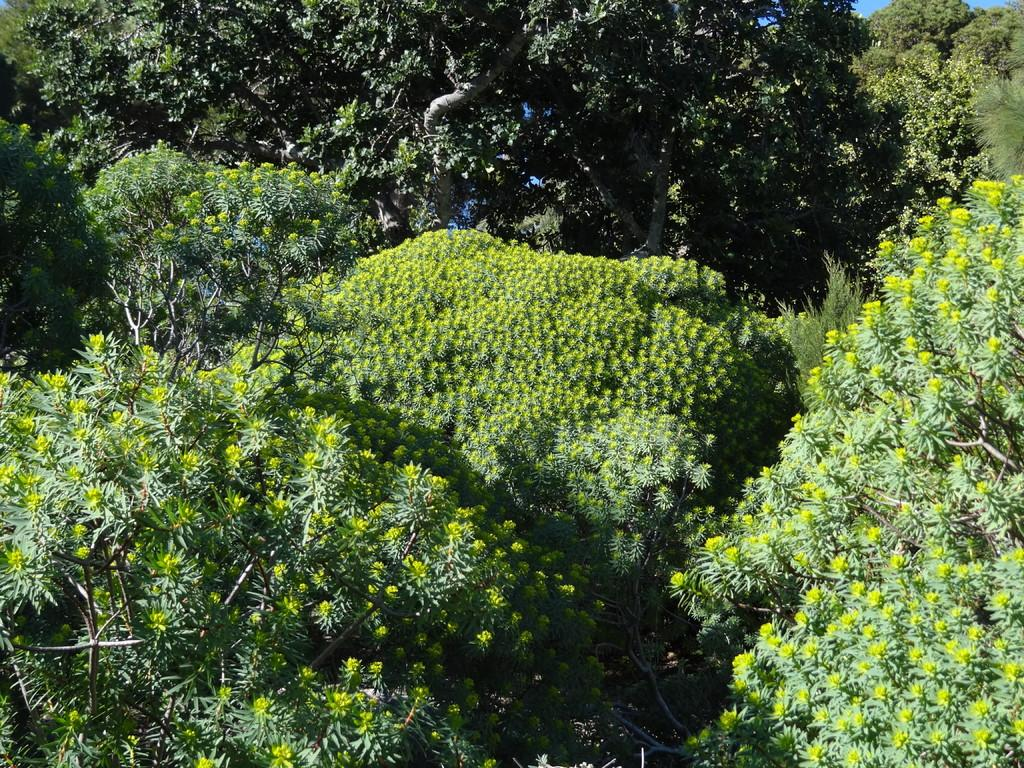What is the primary feature of the image? There are many trees in the image. What can be seen in the background of the image? The sky is blue in the background of the image. How many people are learning from the cows in the image? There are no people or cows present in the image; it features trees and a blue sky. 